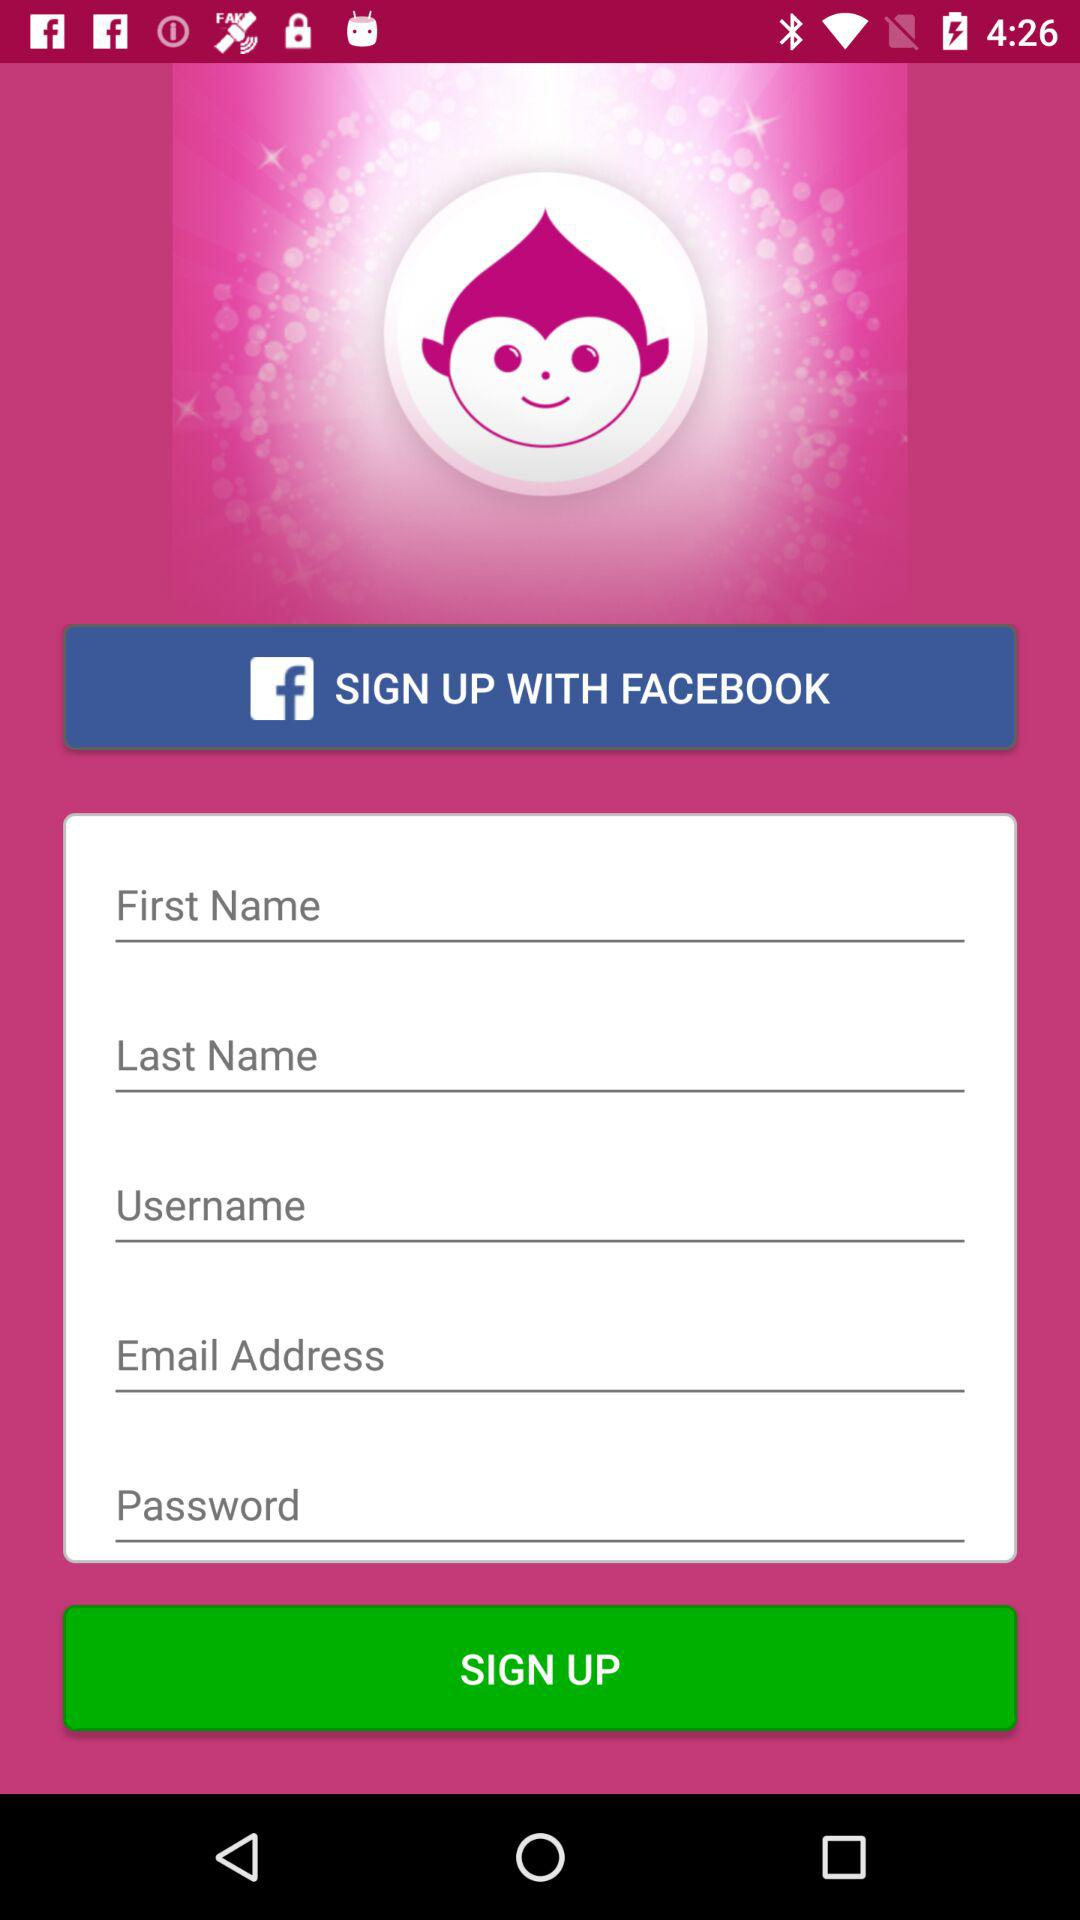What application is used for sign up? The application is Facebook. 